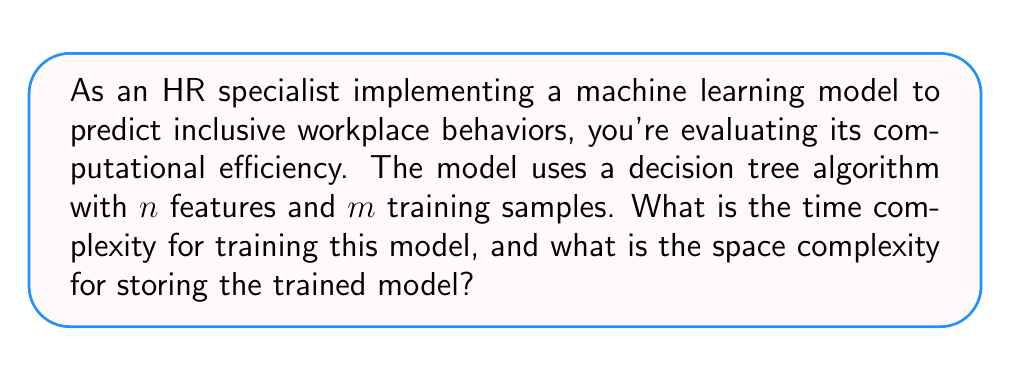Give your solution to this math problem. To answer this question, we need to consider the decision tree algorithm's characteristics:

1. Time Complexity:
   For training a decision tree:
   - At each node, we need to evaluate all $n$ features for all $m$ samples to find the best split.
   - In the worst case, the tree can have a depth of $m$ (one sample per leaf).
   - At each level, we're working with fewer samples, but in the worst case, we can consider it to be $m$ for all levels.

   Therefore, the time complexity for training is:
   $$O(n \times m \times m) = O(n \times m^2)$$

2. Space Complexity:
   For storing the trained model:
   - In the worst case, we might have a leaf for each training sample.
   - Each node stores a feature index and a threshold value.

   The space complexity is thus proportional to the number of nodes, which in the worst case is:
   $$O(m)$$

It's important to note that this is a worst-case analysis. In practice, with proper stopping criteria and pruning techniques, the complexity can be significantly lower.

For an HR specialist focusing on DEI strategies, understanding these complexities is crucial when implementing such models, as they impact the scalability and resource requirements of the predictive system for inclusive workplace behaviors.
Answer: Time Complexity: $O(n \times m^2)$
Space Complexity: $O(m)$

Where $n$ is the number of features and $m$ is the number of training samples. 